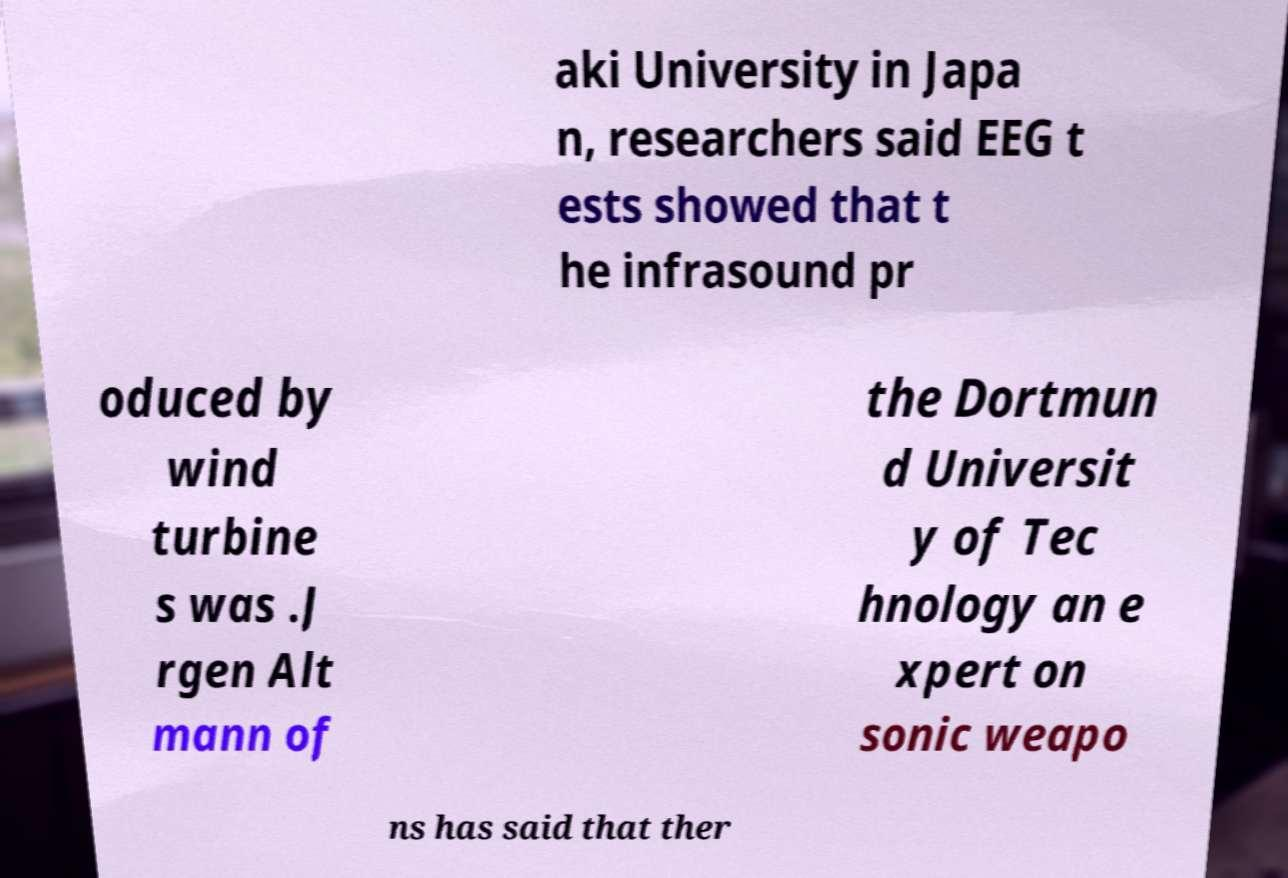Please read and relay the text visible in this image. What does it say? aki University in Japa n, researchers said EEG t ests showed that t he infrasound pr oduced by wind turbine s was .J rgen Alt mann of the Dortmun d Universit y of Tec hnology an e xpert on sonic weapo ns has said that ther 